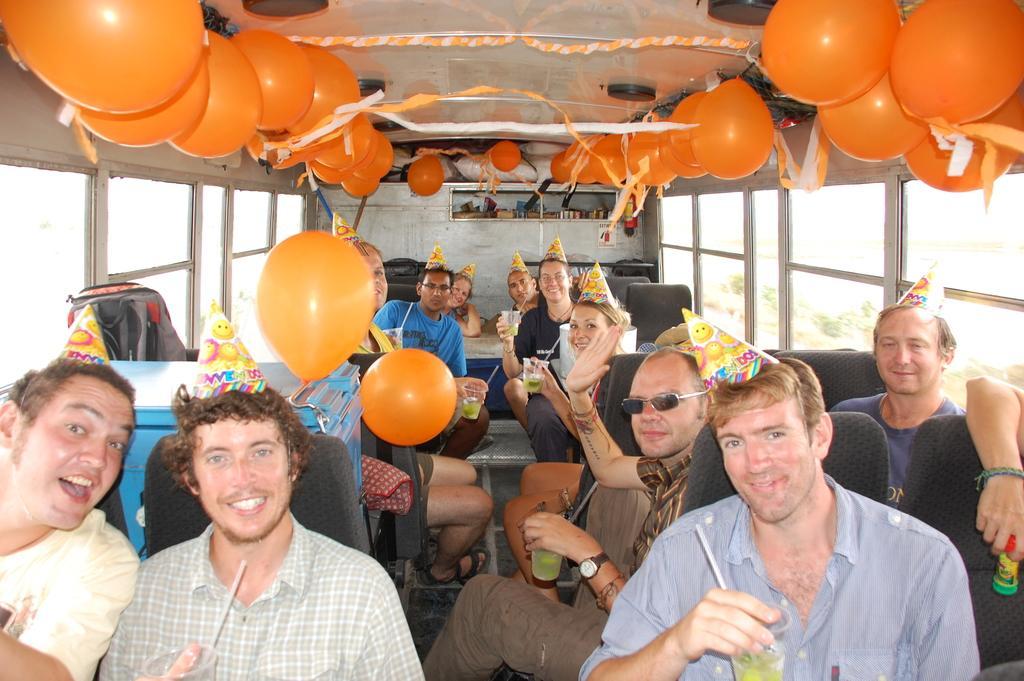Could you give a brief overview of what you see in this image? This picture shows few people seated in a vehicle and we see balloons and color papers and few of them wore caps and few are holding glasses in their hands and we see smile on their faces. 